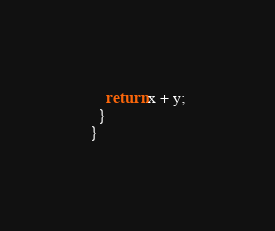<code> <loc_0><loc_0><loc_500><loc_500><_Java_>    return x + y;
  }
}
</code> 